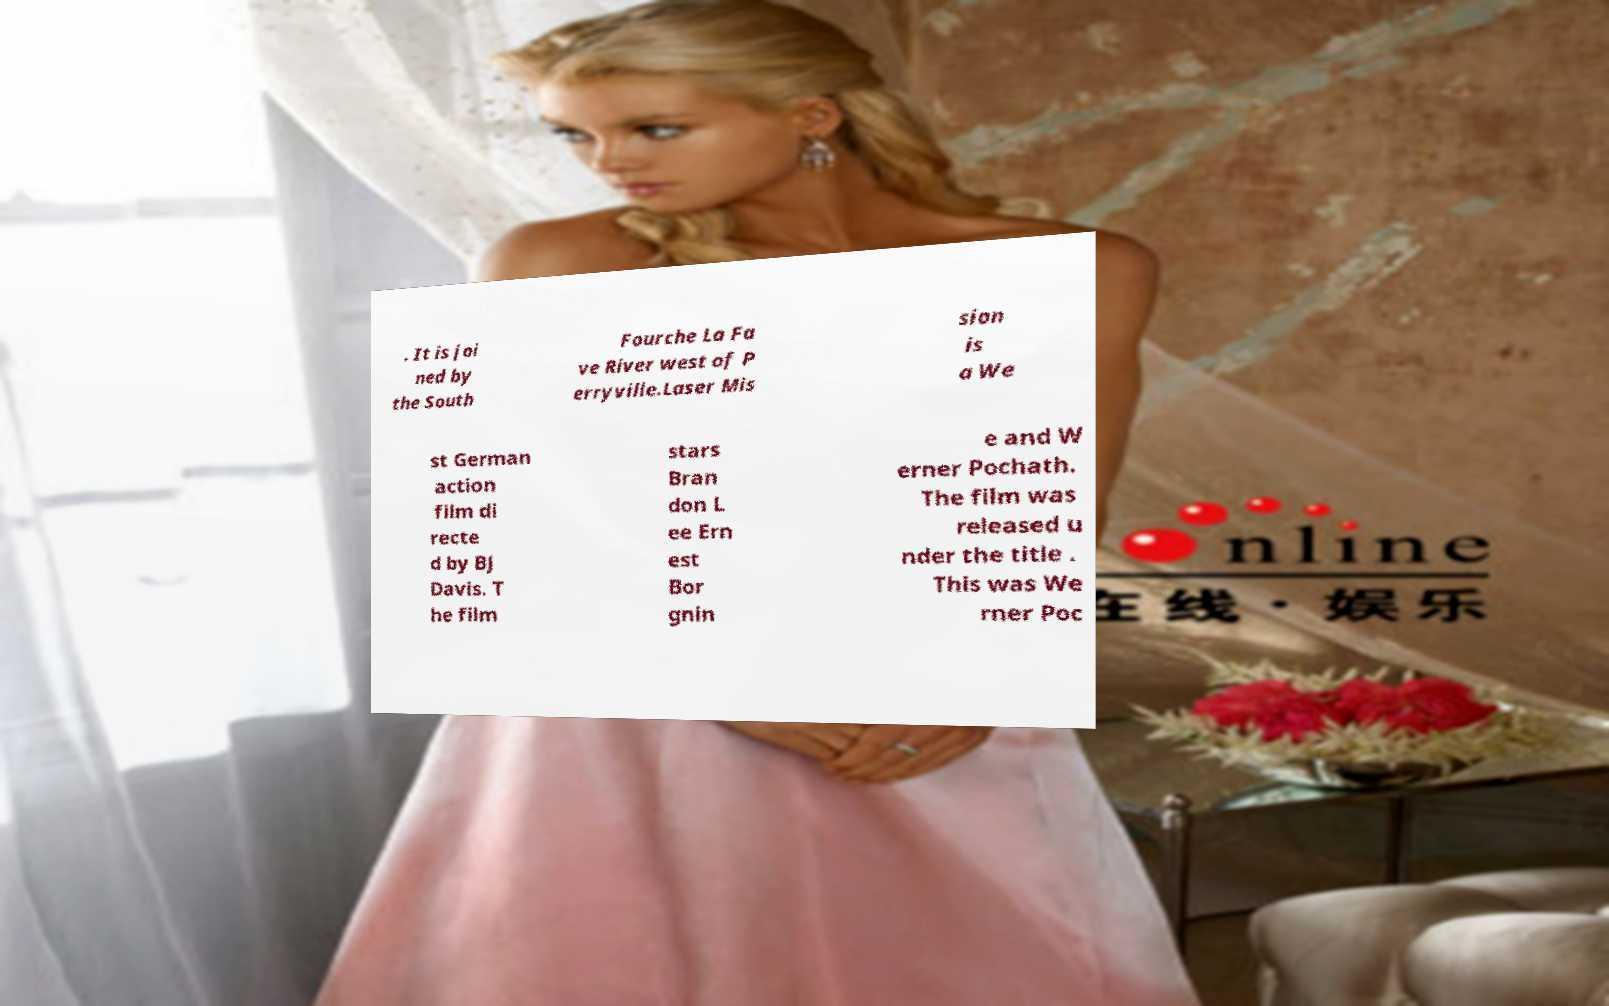What messages or text are displayed in this image? I need them in a readable, typed format. . It is joi ned by the South Fourche La Fa ve River west of P erryville.Laser Mis sion is a We st German action film di recte d by BJ Davis. T he film stars Bran don L ee Ern est Bor gnin e and W erner Pochath. The film was released u nder the title . This was We rner Poc 